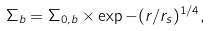Convert formula to latex. <formula><loc_0><loc_0><loc_500><loc_500>\Sigma _ { b } = \Sigma _ { 0 , b } \times \exp { - ( r / r _ { s } ) ^ { 1 / 4 } } ,</formula> 